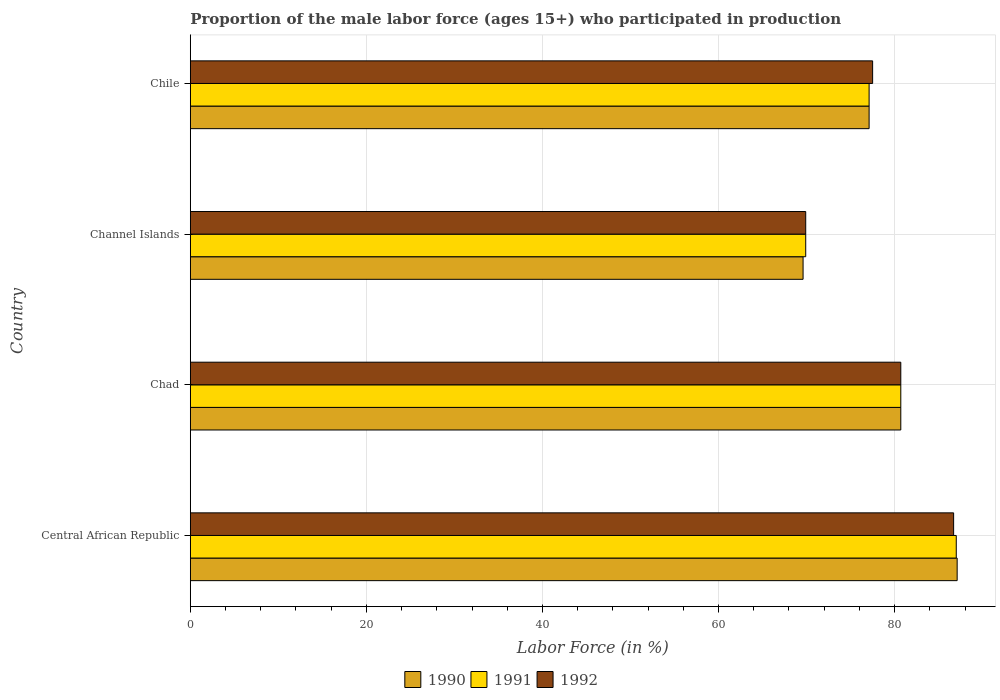How many bars are there on the 4th tick from the bottom?
Give a very brief answer. 3. What is the label of the 2nd group of bars from the top?
Ensure brevity in your answer.  Channel Islands. What is the proportion of the male labor force who participated in production in 1992 in Channel Islands?
Provide a short and direct response. 69.9. Across all countries, what is the maximum proportion of the male labor force who participated in production in 1990?
Provide a short and direct response. 87.1. Across all countries, what is the minimum proportion of the male labor force who participated in production in 1990?
Ensure brevity in your answer.  69.6. In which country was the proportion of the male labor force who participated in production in 1992 maximum?
Keep it short and to the point. Central African Republic. In which country was the proportion of the male labor force who participated in production in 1990 minimum?
Ensure brevity in your answer.  Channel Islands. What is the total proportion of the male labor force who participated in production in 1991 in the graph?
Your answer should be very brief. 314.7. What is the difference between the proportion of the male labor force who participated in production in 1992 in Central African Republic and that in Channel Islands?
Provide a short and direct response. 16.8. What is the difference between the proportion of the male labor force who participated in production in 1990 in Central African Republic and the proportion of the male labor force who participated in production in 1992 in Chile?
Ensure brevity in your answer.  9.6. What is the average proportion of the male labor force who participated in production in 1990 per country?
Provide a succinct answer. 78.62. What is the difference between the proportion of the male labor force who participated in production in 1991 and proportion of the male labor force who participated in production in 1992 in Chad?
Provide a short and direct response. 0. What is the ratio of the proportion of the male labor force who participated in production in 1992 in Chad to that in Chile?
Ensure brevity in your answer.  1.04. Is the proportion of the male labor force who participated in production in 1992 in Channel Islands less than that in Chile?
Make the answer very short. Yes. What is the difference between the highest and the second highest proportion of the male labor force who participated in production in 1990?
Provide a succinct answer. 6.4. What is the difference between the highest and the lowest proportion of the male labor force who participated in production in 1991?
Keep it short and to the point. 17.1. In how many countries, is the proportion of the male labor force who participated in production in 1991 greater than the average proportion of the male labor force who participated in production in 1991 taken over all countries?
Give a very brief answer. 2. Is the sum of the proportion of the male labor force who participated in production in 1992 in Central African Republic and Channel Islands greater than the maximum proportion of the male labor force who participated in production in 1991 across all countries?
Provide a short and direct response. Yes. What does the 3rd bar from the bottom in Central African Republic represents?
Offer a terse response. 1992. Is it the case that in every country, the sum of the proportion of the male labor force who participated in production in 1990 and proportion of the male labor force who participated in production in 1991 is greater than the proportion of the male labor force who participated in production in 1992?
Provide a short and direct response. Yes. How many bars are there?
Give a very brief answer. 12. Are all the bars in the graph horizontal?
Your response must be concise. Yes. How many countries are there in the graph?
Your answer should be compact. 4. How many legend labels are there?
Make the answer very short. 3. What is the title of the graph?
Your answer should be very brief. Proportion of the male labor force (ages 15+) who participated in production. What is the label or title of the X-axis?
Offer a terse response. Labor Force (in %). What is the label or title of the Y-axis?
Keep it short and to the point. Country. What is the Labor Force (in %) of 1990 in Central African Republic?
Provide a short and direct response. 87.1. What is the Labor Force (in %) of 1992 in Central African Republic?
Give a very brief answer. 86.7. What is the Labor Force (in %) in 1990 in Chad?
Provide a succinct answer. 80.7. What is the Labor Force (in %) of 1991 in Chad?
Offer a terse response. 80.7. What is the Labor Force (in %) in 1992 in Chad?
Your answer should be very brief. 80.7. What is the Labor Force (in %) of 1990 in Channel Islands?
Offer a very short reply. 69.6. What is the Labor Force (in %) of 1991 in Channel Islands?
Provide a succinct answer. 69.9. What is the Labor Force (in %) in 1992 in Channel Islands?
Your answer should be compact. 69.9. What is the Labor Force (in %) of 1990 in Chile?
Give a very brief answer. 77.1. What is the Labor Force (in %) in 1991 in Chile?
Your answer should be compact. 77.1. What is the Labor Force (in %) of 1992 in Chile?
Give a very brief answer. 77.5. Across all countries, what is the maximum Labor Force (in %) in 1990?
Offer a terse response. 87.1. Across all countries, what is the maximum Labor Force (in %) in 1991?
Ensure brevity in your answer.  87. Across all countries, what is the maximum Labor Force (in %) of 1992?
Offer a terse response. 86.7. Across all countries, what is the minimum Labor Force (in %) in 1990?
Ensure brevity in your answer.  69.6. Across all countries, what is the minimum Labor Force (in %) in 1991?
Your answer should be compact. 69.9. Across all countries, what is the minimum Labor Force (in %) in 1992?
Offer a very short reply. 69.9. What is the total Labor Force (in %) in 1990 in the graph?
Your answer should be compact. 314.5. What is the total Labor Force (in %) of 1991 in the graph?
Your answer should be compact. 314.7. What is the total Labor Force (in %) in 1992 in the graph?
Make the answer very short. 314.8. What is the difference between the Labor Force (in %) of 1991 in Central African Republic and that in Channel Islands?
Provide a short and direct response. 17.1. What is the difference between the Labor Force (in %) of 1991 in Central African Republic and that in Chile?
Make the answer very short. 9.9. What is the difference between the Labor Force (in %) in 1992 in Central African Republic and that in Chile?
Your answer should be very brief. 9.2. What is the difference between the Labor Force (in %) in 1991 in Chad and that in Chile?
Ensure brevity in your answer.  3.6. What is the difference between the Labor Force (in %) of 1990 in Channel Islands and that in Chile?
Offer a very short reply. -7.5. What is the difference between the Labor Force (in %) of 1990 in Central African Republic and the Labor Force (in %) of 1991 in Chad?
Provide a succinct answer. 6.4. What is the difference between the Labor Force (in %) in 1990 in Central African Republic and the Labor Force (in %) in 1992 in Chad?
Give a very brief answer. 6.4. What is the difference between the Labor Force (in %) of 1991 in Central African Republic and the Labor Force (in %) of 1992 in Chad?
Provide a succinct answer. 6.3. What is the difference between the Labor Force (in %) in 1990 in Central African Republic and the Labor Force (in %) in 1991 in Channel Islands?
Ensure brevity in your answer.  17.2. What is the difference between the Labor Force (in %) in 1990 in Central African Republic and the Labor Force (in %) in 1992 in Chile?
Your response must be concise. 9.6. What is the difference between the Labor Force (in %) in 1990 in Chad and the Labor Force (in %) in 1991 in Channel Islands?
Provide a short and direct response. 10.8. What is the difference between the Labor Force (in %) of 1990 in Chad and the Labor Force (in %) of 1992 in Channel Islands?
Offer a very short reply. 10.8. What is the difference between the Labor Force (in %) in 1990 in Chad and the Labor Force (in %) in 1991 in Chile?
Your response must be concise. 3.6. What is the average Labor Force (in %) in 1990 per country?
Keep it short and to the point. 78.62. What is the average Labor Force (in %) in 1991 per country?
Offer a very short reply. 78.67. What is the average Labor Force (in %) in 1992 per country?
Your response must be concise. 78.7. What is the difference between the Labor Force (in %) in 1990 and Labor Force (in %) in 1991 in Central African Republic?
Make the answer very short. 0.1. What is the difference between the Labor Force (in %) of 1990 and Labor Force (in %) of 1992 in Central African Republic?
Offer a terse response. 0.4. What is the difference between the Labor Force (in %) in 1990 and Labor Force (in %) in 1992 in Chad?
Your answer should be very brief. 0. What is the difference between the Labor Force (in %) of 1991 and Labor Force (in %) of 1992 in Chad?
Provide a short and direct response. 0. What is the difference between the Labor Force (in %) of 1990 and Labor Force (in %) of 1991 in Channel Islands?
Offer a terse response. -0.3. What is the difference between the Labor Force (in %) of 1990 and Labor Force (in %) of 1992 in Channel Islands?
Your response must be concise. -0.3. What is the difference between the Labor Force (in %) in 1991 and Labor Force (in %) in 1992 in Channel Islands?
Give a very brief answer. 0. What is the difference between the Labor Force (in %) in 1990 and Labor Force (in %) in 1991 in Chile?
Your response must be concise. 0. What is the difference between the Labor Force (in %) in 1990 and Labor Force (in %) in 1992 in Chile?
Your answer should be very brief. -0.4. What is the ratio of the Labor Force (in %) in 1990 in Central African Republic to that in Chad?
Provide a short and direct response. 1.08. What is the ratio of the Labor Force (in %) in 1991 in Central African Republic to that in Chad?
Give a very brief answer. 1.08. What is the ratio of the Labor Force (in %) of 1992 in Central African Republic to that in Chad?
Provide a succinct answer. 1.07. What is the ratio of the Labor Force (in %) in 1990 in Central African Republic to that in Channel Islands?
Your response must be concise. 1.25. What is the ratio of the Labor Force (in %) of 1991 in Central African Republic to that in Channel Islands?
Ensure brevity in your answer.  1.24. What is the ratio of the Labor Force (in %) of 1992 in Central African Republic to that in Channel Islands?
Your answer should be compact. 1.24. What is the ratio of the Labor Force (in %) of 1990 in Central African Republic to that in Chile?
Your response must be concise. 1.13. What is the ratio of the Labor Force (in %) of 1991 in Central African Republic to that in Chile?
Provide a short and direct response. 1.13. What is the ratio of the Labor Force (in %) of 1992 in Central African Republic to that in Chile?
Offer a terse response. 1.12. What is the ratio of the Labor Force (in %) in 1990 in Chad to that in Channel Islands?
Your answer should be compact. 1.16. What is the ratio of the Labor Force (in %) in 1991 in Chad to that in Channel Islands?
Provide a short and direct response. 1.15. What is the ratio of the Labor Force (in %) of 1992 in Chad to that in Channel Islands?
Provide a succinct answer. 1.15. What is the ratio of the Labor Force (in %) in 1990 in Chad to that in Chile?
Your response must be concise. 1.05. What is the ratio of the Labor Force (in %) in 1991 in Chad to that in Chile?
Keep it short and to the point. 1.05. What is the ratio of the Labor Force (in %) in 1992 in Chad to that in Chile?
Ensure brevity in your answer.  1.04. What is the ratio of the Labor Force (in %) of 1990 in Channel Islands to that in Chile?
Ensure brevity in your answer.  0.9. What is the ratio of the Labor Force (in %) in 1991 in Channel Islands to that in Chile?
Provide a succinct answer. 0.91. What is the ratio of the Labor Force (in %) in 1992 in Channel Islands to that in Chile?
Ensure brevity in your answer.  0.9. What is the difference between the highest and the second highest Labor Force (in %) in 1990?
Make the answer very short. 6.4. What is the difference between the highest and the second highest Labor Force (in %) in 1991?
Your answer should be compact. 6.3. What is the difference between the highest and the lowest Labor Force (in %) of 1992?
Offer a very short reply. 16.8. 